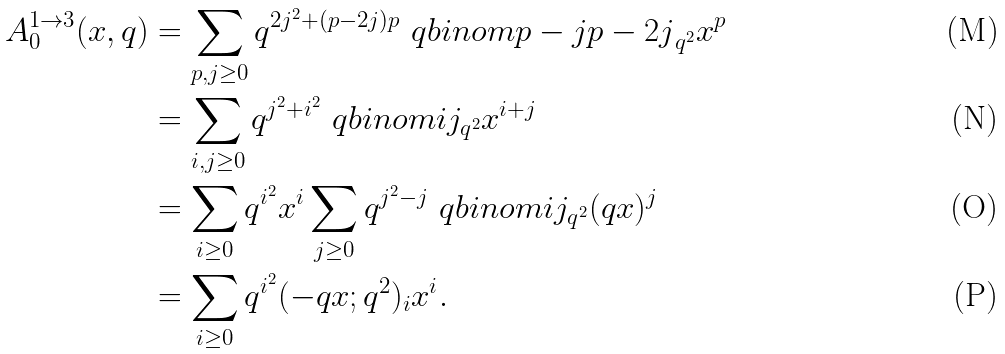<formula> <loc_0><loc_0><loc_500><loc_500>A _ { 0 } ^ { 1 \rightarrow 3 } ( x , q ) & = \sum _ { p , j \geq 0 } q ^ { 2 j ^ { 2 } + ( p - 2 j ) p } \ q b i n o m { p - j } { p - 2 j } _ { q ^ { 2 } } x ^ { p } & \\ & = \sum _ { i , j \geq 0 } q ^ { j ^ { 2 } + i ^ { 2 } } \ q b i n o m { i } { j } _ { q ^ { 2 } } x ^ { i + j } & \\ & = \sum _ { i \geq 0 } q ^ { i ^ { 2 } } x ^ { i } \sum _ { j \geq 0 } q ^ { j ^ { 2 } - j } \ q b i n o m { i } { j } _ { q ^ { 2 } } ( q x ) ^ { j } & \\ & = \sum _ { i \geq 0 } q ^ { i ^ { 2 } } ( - q x ; q ^ { 2 } ) _ { i } x ^ { i } .</formula> 